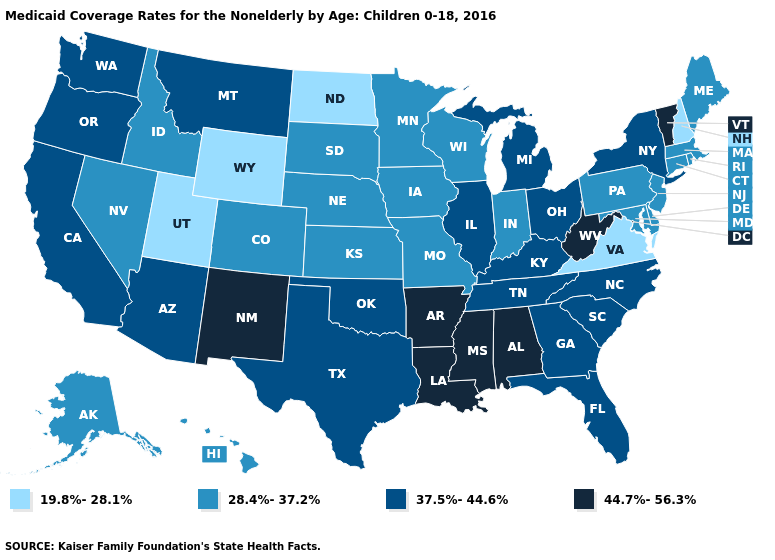Does Virginia have the lowest value in the USA?
Quick response, please. Yes. What is the highest value in the West ?
Give a very brief answer. 44.7%-56.3%. Name the states that have a value in the range 19.8%-28.1%?
Give a very brief answer. New Hampshire, North Dakota, Utah, Virginia, Wyoming. How many symbols are there in the legend?
Short answer required. 4. Does Rhode Island have the highest value in the Northeast?
Short answer required. No. What is the highest value in states that border Florida?
Be succinct. 44.7%-56.3%. What is the value of Nevada?
Be succinct. 28.4%-37.2%. Which states have the lowest value in the USA?
Give a very brief answer. New Hampshire, North Dakota, Utah, Virginia, Wyoming. What is the value of Wyoming?
Be succinct. 19.8%-28.1%. Does Maine have a lower value than South Dakota?
Answer briefly. No. Does Arkansas have the highest value in the USA?
Answer briefly. Yes. Among the states that border Oregon , does Nevada have the lowest value?
Quick response, please. Yes. Among the states that border New Hampshire , which have the highest value?
Quick response, please. Vermont. What is the value of West Virginia?
Concise answer only. 44.7%-56.3%. Which states hav the highest value in the MidWest?
Be succinct. Illinois, Michigan, Ohio. 